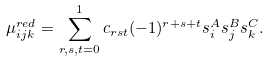<formula> <loc_0><loc_0><loc_500><loc_500>\mu _ { i j k } ^ { r e d } = \sum _ { r , s , t = 0 } ^ { 1 } c _ { r s t } ( - 1 ) ^ { r + s + t } s ^ { A } _ { i } s ^ { B } _ { j } s ^ { C } _ { k } .</formula> 